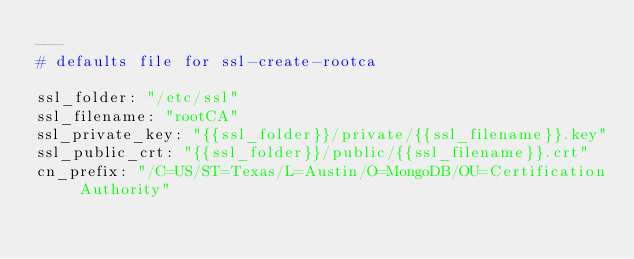<code> <loc_0><loc_0><loc_500><loc_500><_YAML_>---
# defaults file for ssl-create-rootca

ssl_folder: "/etc/ssl"
ssl_filename: "rootCA"
ssl_private_key: "{{ssl_folder}}/private/{{ssl_filename}}.key"
ssl_public_crt: "{{ssl_folder}}/public/{{ssl_filename}}.crt"
cn_prefix: "/C=US/ST=Texas/L=Austin/O=MongoDB/OU=Certification Authority"</code> 